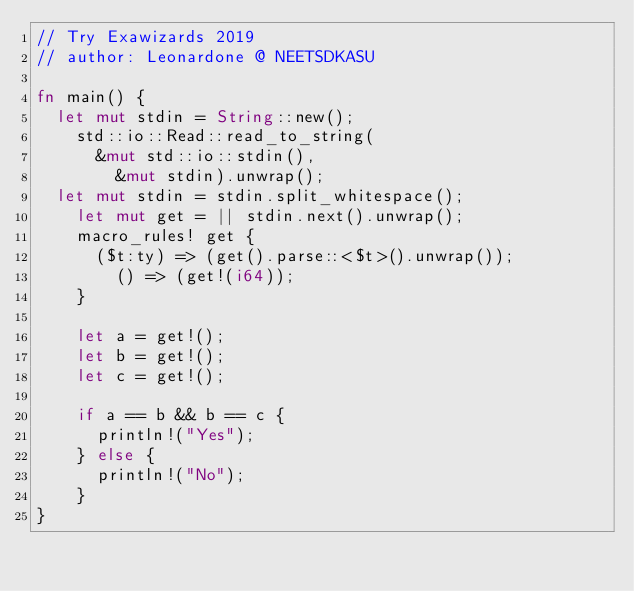<code> <loc_0><loc_0><loc_500><loc_500><_Rust_>// Try Exawizards 2019
// author: Leonardone @ NEETSDKASU

fn main() {
	let mut stdin = String::new();
    std::io::Read::read_to_string(
    	&mut std::io::stdin(),
        &mut stdin).unwrap();
	let mut stdin = stdin.split_whitespace();
    let mut get = || stdin.next().unwrap();
    macro_rules! get {
    	($t:ty) => (get().parse::<$t>().unwrap());
        () => (get!(i64));
    }
    
    let a = get!();
    let b = get!();
    let c = get!();
    
    if a == b && b == c {
    	println!("Yes");
    } else {
    	println!("No");
    }
}</code> 